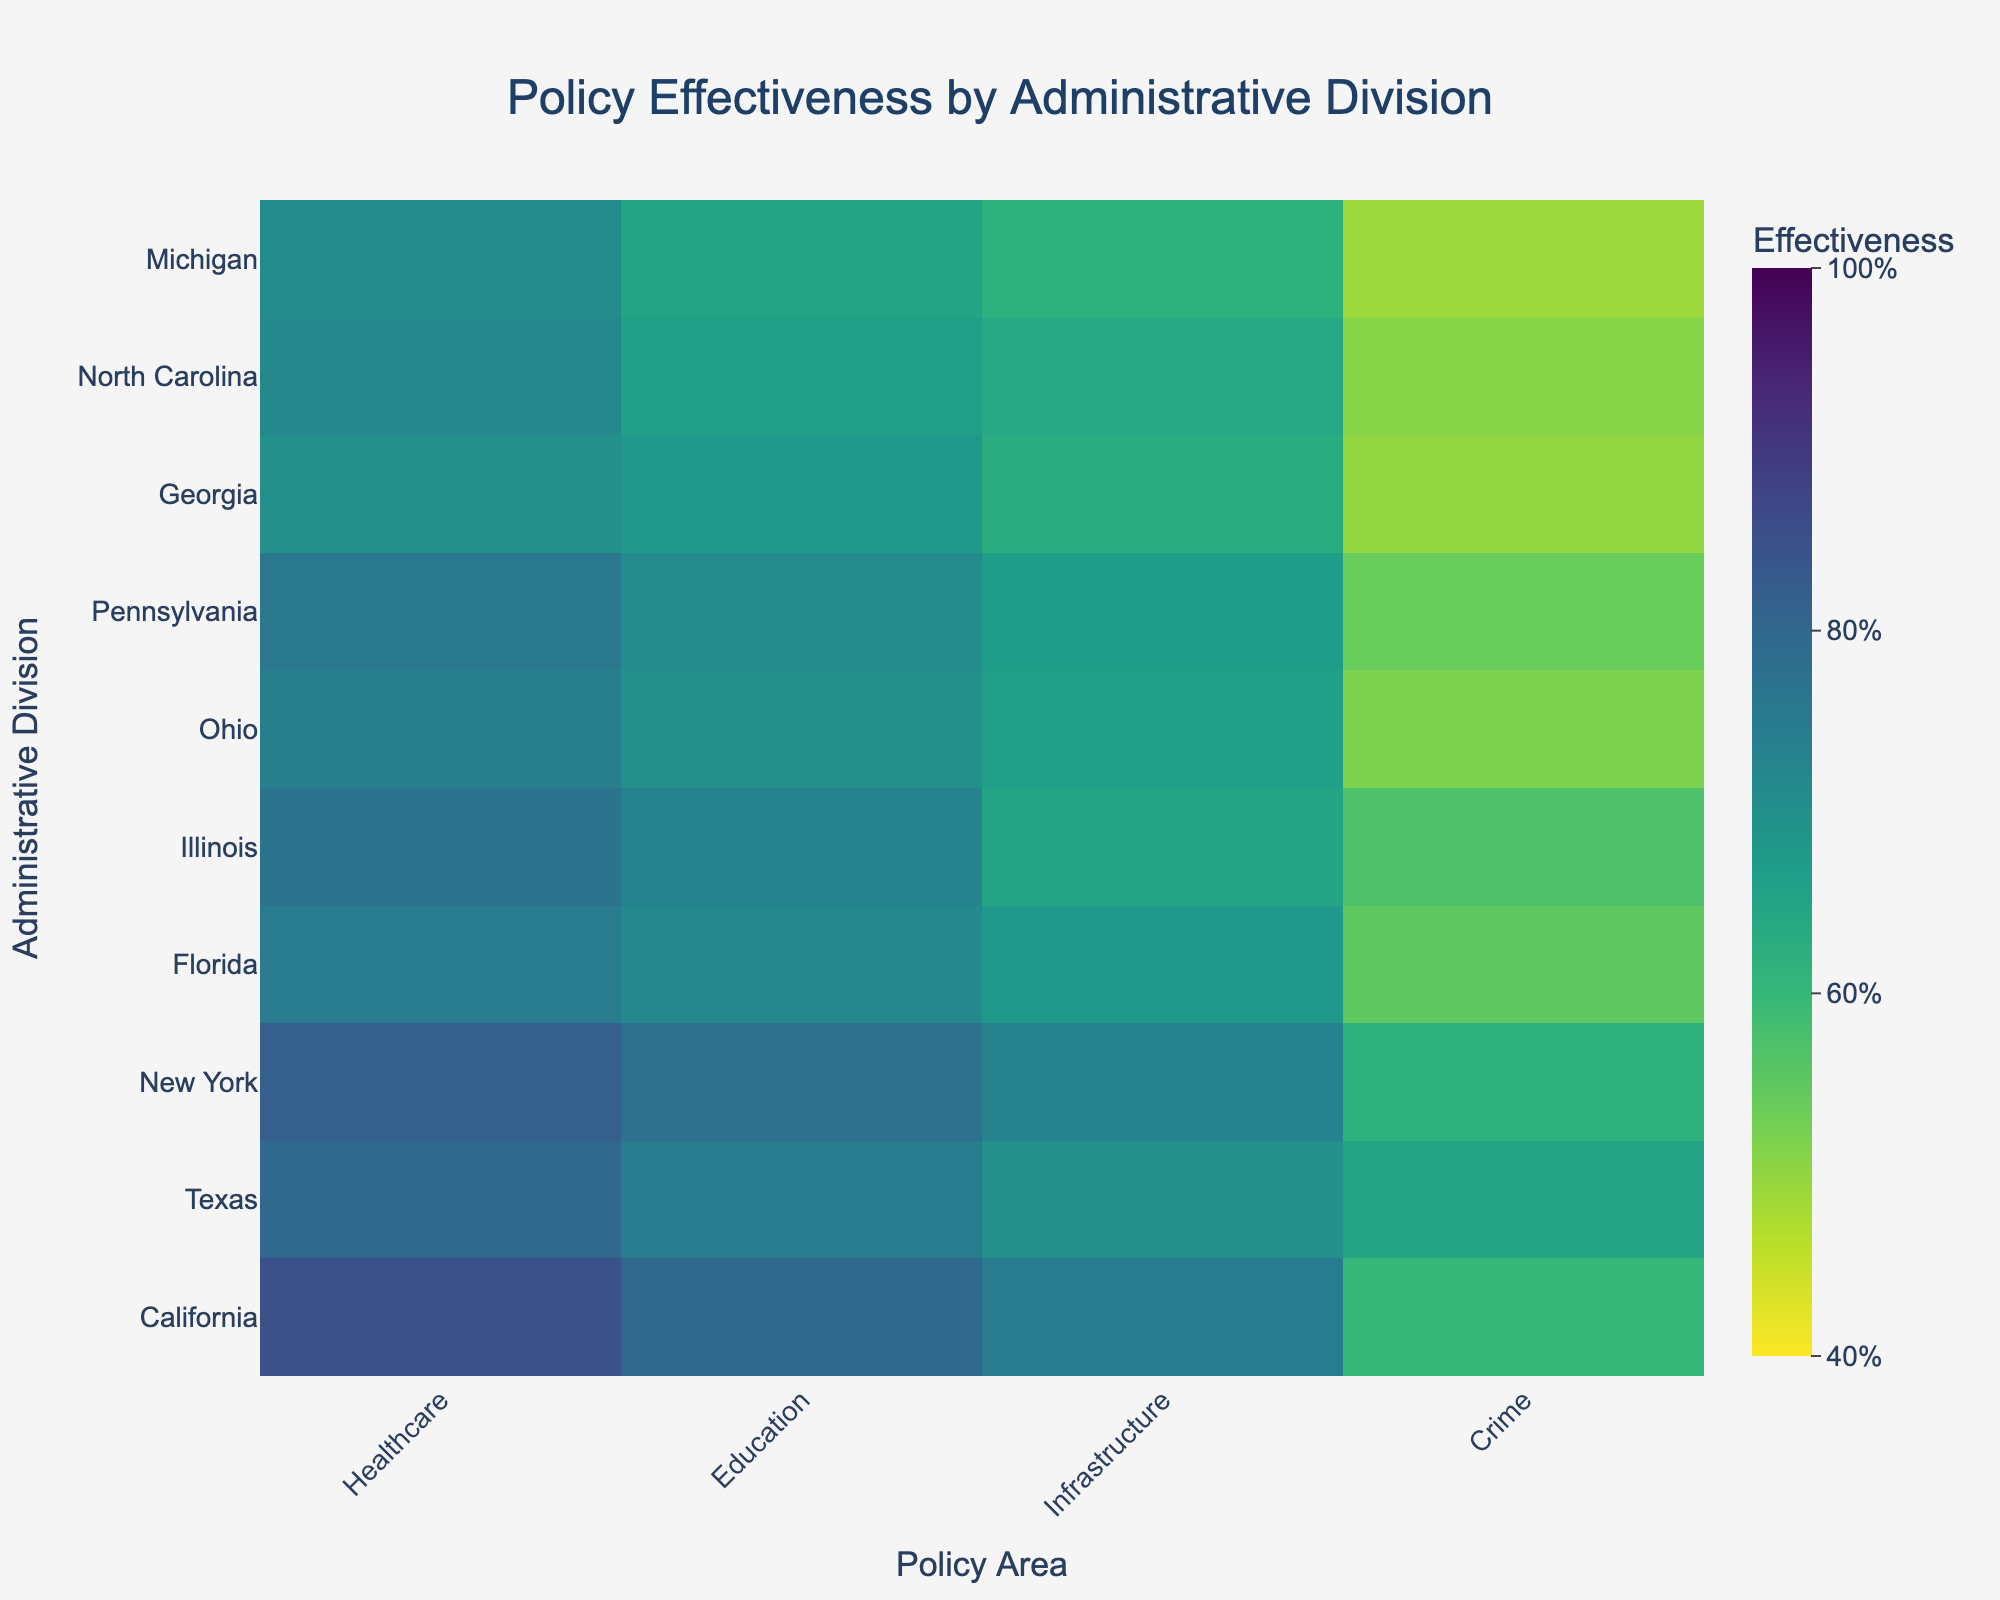What policy area has the highest effectiveness in California? From the heatmap, we identify the row for California and locate the highest value across the columns for different policy areas. The highest value is 85 under 'Healthcare Effectiveness.'
Answer: Healthcare What is the average effectiveness of Infrastructure policies across all regions? Sum the 'Infrastructure Effectiveness' values for all regions then divide by the number of regions. The values are 75, 70, 73, 68, 65, 66, 67, 63, 64, and 62 making a total of 673. Divide 673 by 10 regions to get the average 67.3.
Answer: 67.3 Which regions have a higher Education Effectiveness than Healthcare Effectiveness? Compare 'Education Effectiveness' to 'Healthcare Effectiveness' for each region. Only Illinois and North Carolina have 'Education Effectiveness' higher than 'Healthcare Effectiveness' values.
Answer: Illinois, North Carolina How much more effective is crime reduction in Texas compared to Michigan? Locate and compare the 'Crime Reduction Effectiveness' for Texas (65) and Michigan (49). The difference is 65 - 49 = 16.
Answer: 16 What region has the lowest overall policy effectiveness? Sum the effectiveness values of each policy area for each region and identify the lowest total. Georgia with a total of (70 + 68 + 63 + 50) = 251 has the lowest overall effectiveness.
Answer: Georgia What is the range of Healthcare Effectiveness values across all regions? Identify the minimum and maximum 'Healthcare Effectiveness' values. The minimum is 70 (Georgia) and the maximum is 85 (California). The range is 85 - 70 = 15.
Answer: 15 Which region has the highest combined effectiveness for both Education and Crime Reduction policies? Sum the 'Education Effectiveness' and 'Crime Reduction Effectiveness' values for each region. California has the highest sum (80 + 60) = 140.
Answer: California Between Healthcare and Crime Reduction policies, which one has a wider range of effectiveness values across all regions? Calculate the ranges of both 'Healthcare Effectiveness' and 'Crime Reduction Effectiveness' (max - min values). 'Healthcare' range: 85-70=15 and 'Crime Reduction' range: 65-49=16.
Answer: Crime Reduction Which policy area shows the least variation in effectiveness across regions? Determine the standard deviation for the effectiveness values of each policy area (lower SD means less variation). 'Education Effectiveness' visually varies less across regions compared to other areas.
Answer: Education How effective is the Healthcare policy in New York compared to Ohio? Compare 'Healthcare Effectiveness' values for New York (82) and Ohio (74). The difference is 82 - 74 = 8.
Answer: 8 